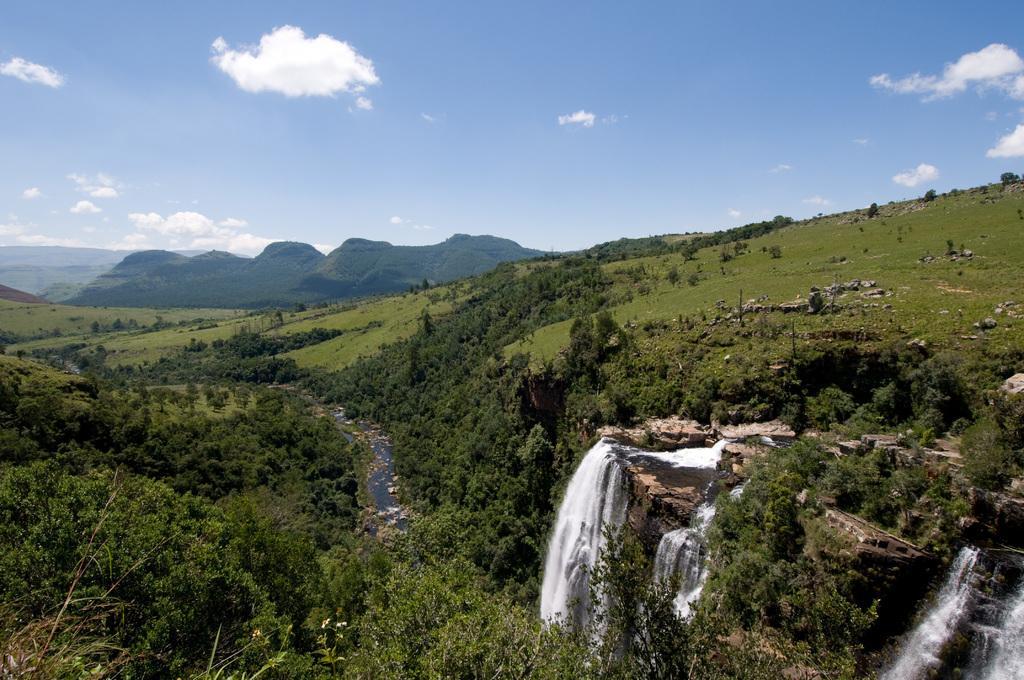In one or two sentences, can you explain what this image depicts? In this image, we can see hills, trees, waterfalls and there are rocks. At the top, there are clouds in the sky. 